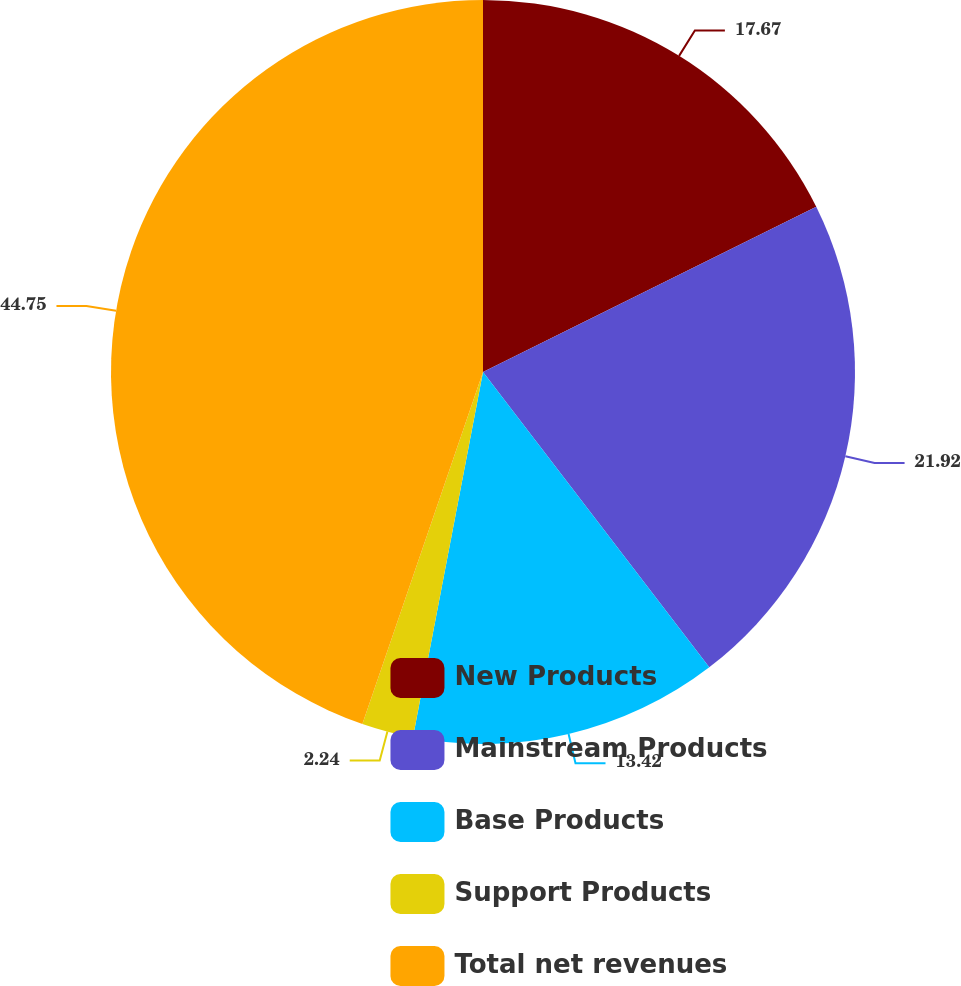<chart> <loc_0><loc_0><loc_500><loc_500><pie_chart><fcel>New Products<fcel>Mainstream Products<fcel>Base Products<fcel>Support Products<fcel>Total net revenues<nl><fcel>17.67%<fcel>21.92%<fcel>13.42%<fcel>2.24%<fcel>44.74%<nl></chart> 